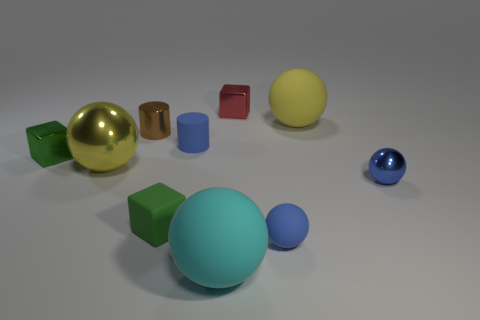There is a tiny cylinder that is on the left side of the small green thing to the right of the small green shiny object; what number of large yellow things are in front of it?
Provide a short and direct response. 1. There is a red object that is the same shape as the green metallic thing; what is it made of?
Keep it short and to the point. Metal. Are there any other things that have the same material as the large cyan thing?
Offer a terse response. Yes. There is a small metallic block that is left of the small brown cylinder; what is its color?
Your response must be concise. Green. Is the material of the red block the same as the tiny blue ball that is behind the small rubber cube?
Your response must be concise. Yes. What is the material of the tiny blue cylinder?
Offer a very short reply. Rubber. What is the shape of the large object that is the same material as the tiny brown thing?
Your answer should be compact. Sphere. What number of other objects are the same shape as the tiny blue metallic thing?
Offer a terse response. 4. What number of blue matte cylinders are in front of the yellow shiny object?
Make the answer very short. 0. There is a blue thing on the left side of the tiny red thing; is it the same size as the green thing behind the tiny blue metallic object?
Give a very brief answer. Yes. 